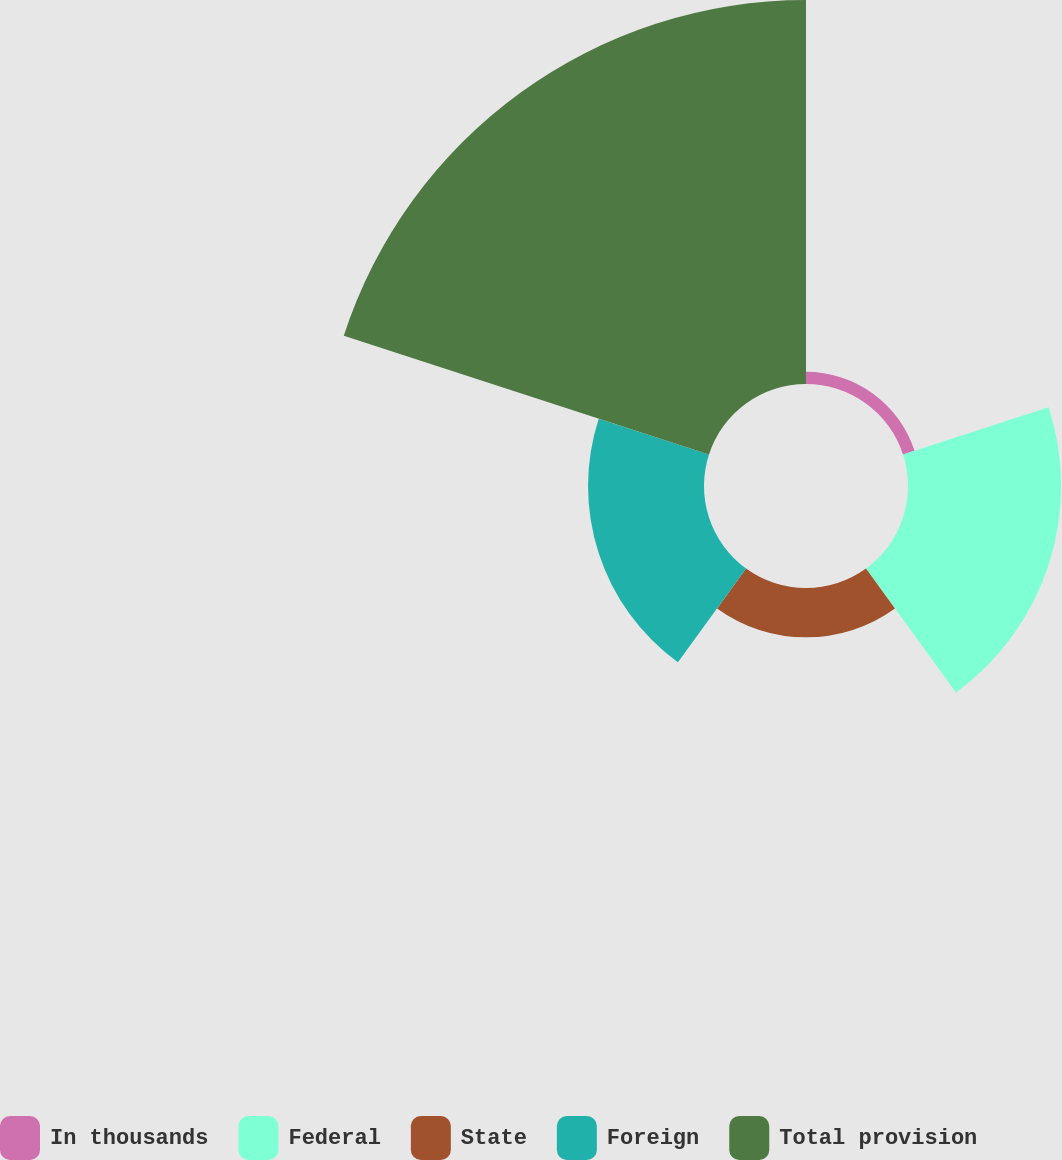Convert chart. <chart><loc_0><loc_0><loc_500><loc_500><pie_chart><fcel>In thousands<fcel>Federal<fcel>State<fcel>Foreign<fcel>Total provision<nl><fcel>1.7%<fcel>21.43%<fcel>6.9%<fcel>16.23%<fcel>53.75%<nl></chart> 